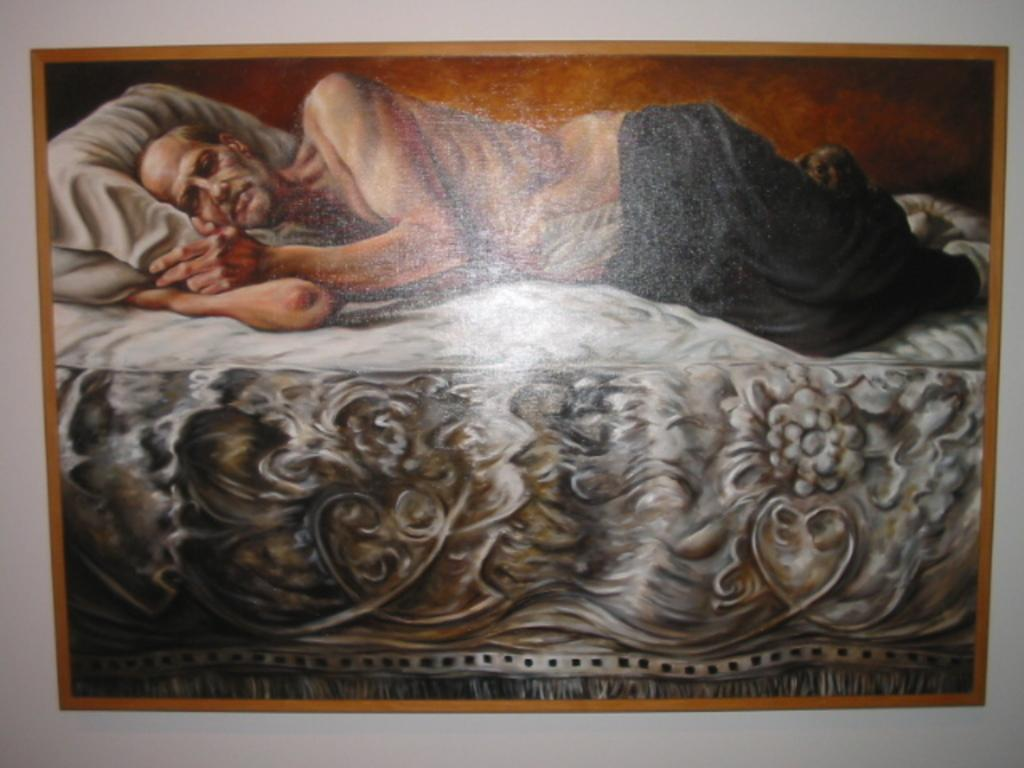What object is present in the image that typically holds a photograph? There is a photo frame in the image. What is depicted in the photo frame? The photo frame contains an image of a person sleeping. Where is the person in the photo frame located? The person in the photo frame is on a bed. Can you see the fireman climbing the mountain in the image? There is no fireman or mountain present in the image. 